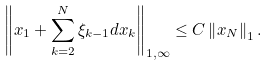<formula> <loc_0><loc_0><loc_500><loc_500>\left \| x _ { 1 } + \sum ^ { N } _ { k = 2 } \xi _ { k - 1 } d x _ { k } \right \| _ { 1 , \infty } \leq C \left \| x _ { N } \right \| _ { 1 } .</formula> 